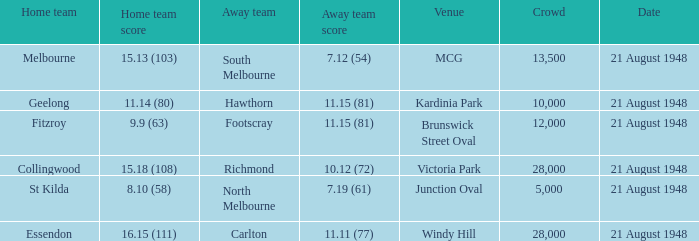When the home team's score was 1 28000.0. 